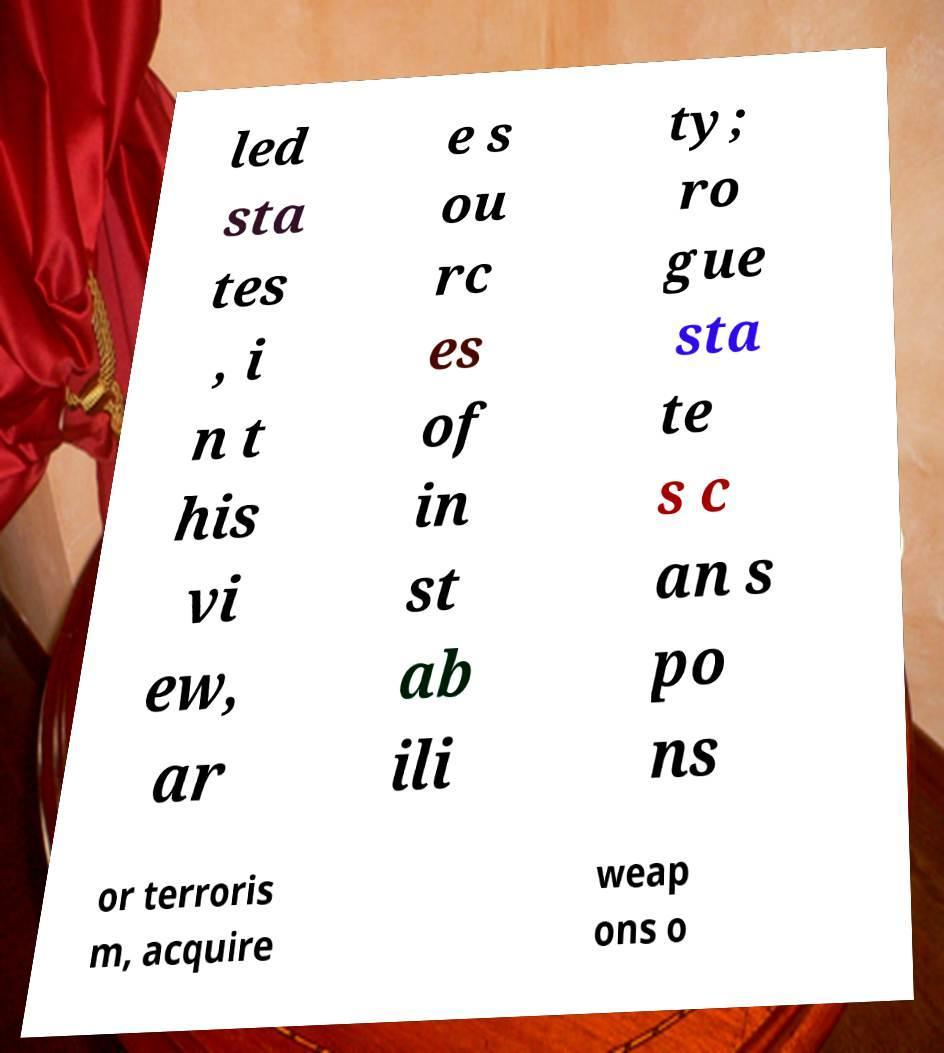For documentation purposes, I need the text within this image transcribed. Could you provide that? led sta tes , i n t his vi ew, ar e s ou rc es of in st ab ili ty; ro gue sta te s c an s po ns or terroris m, acquire weap ons o 